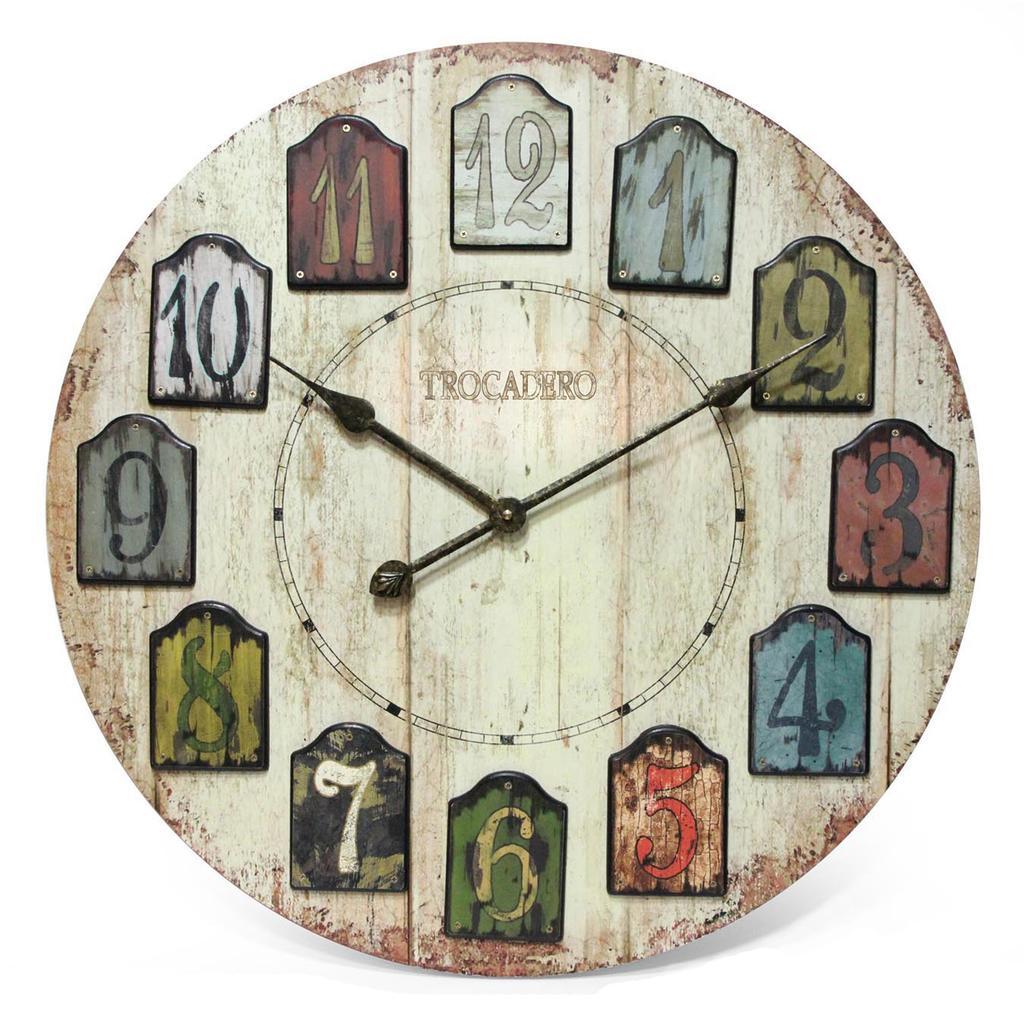<image>
Describe the image concisely. A clock has the word Trocadero on the face. 